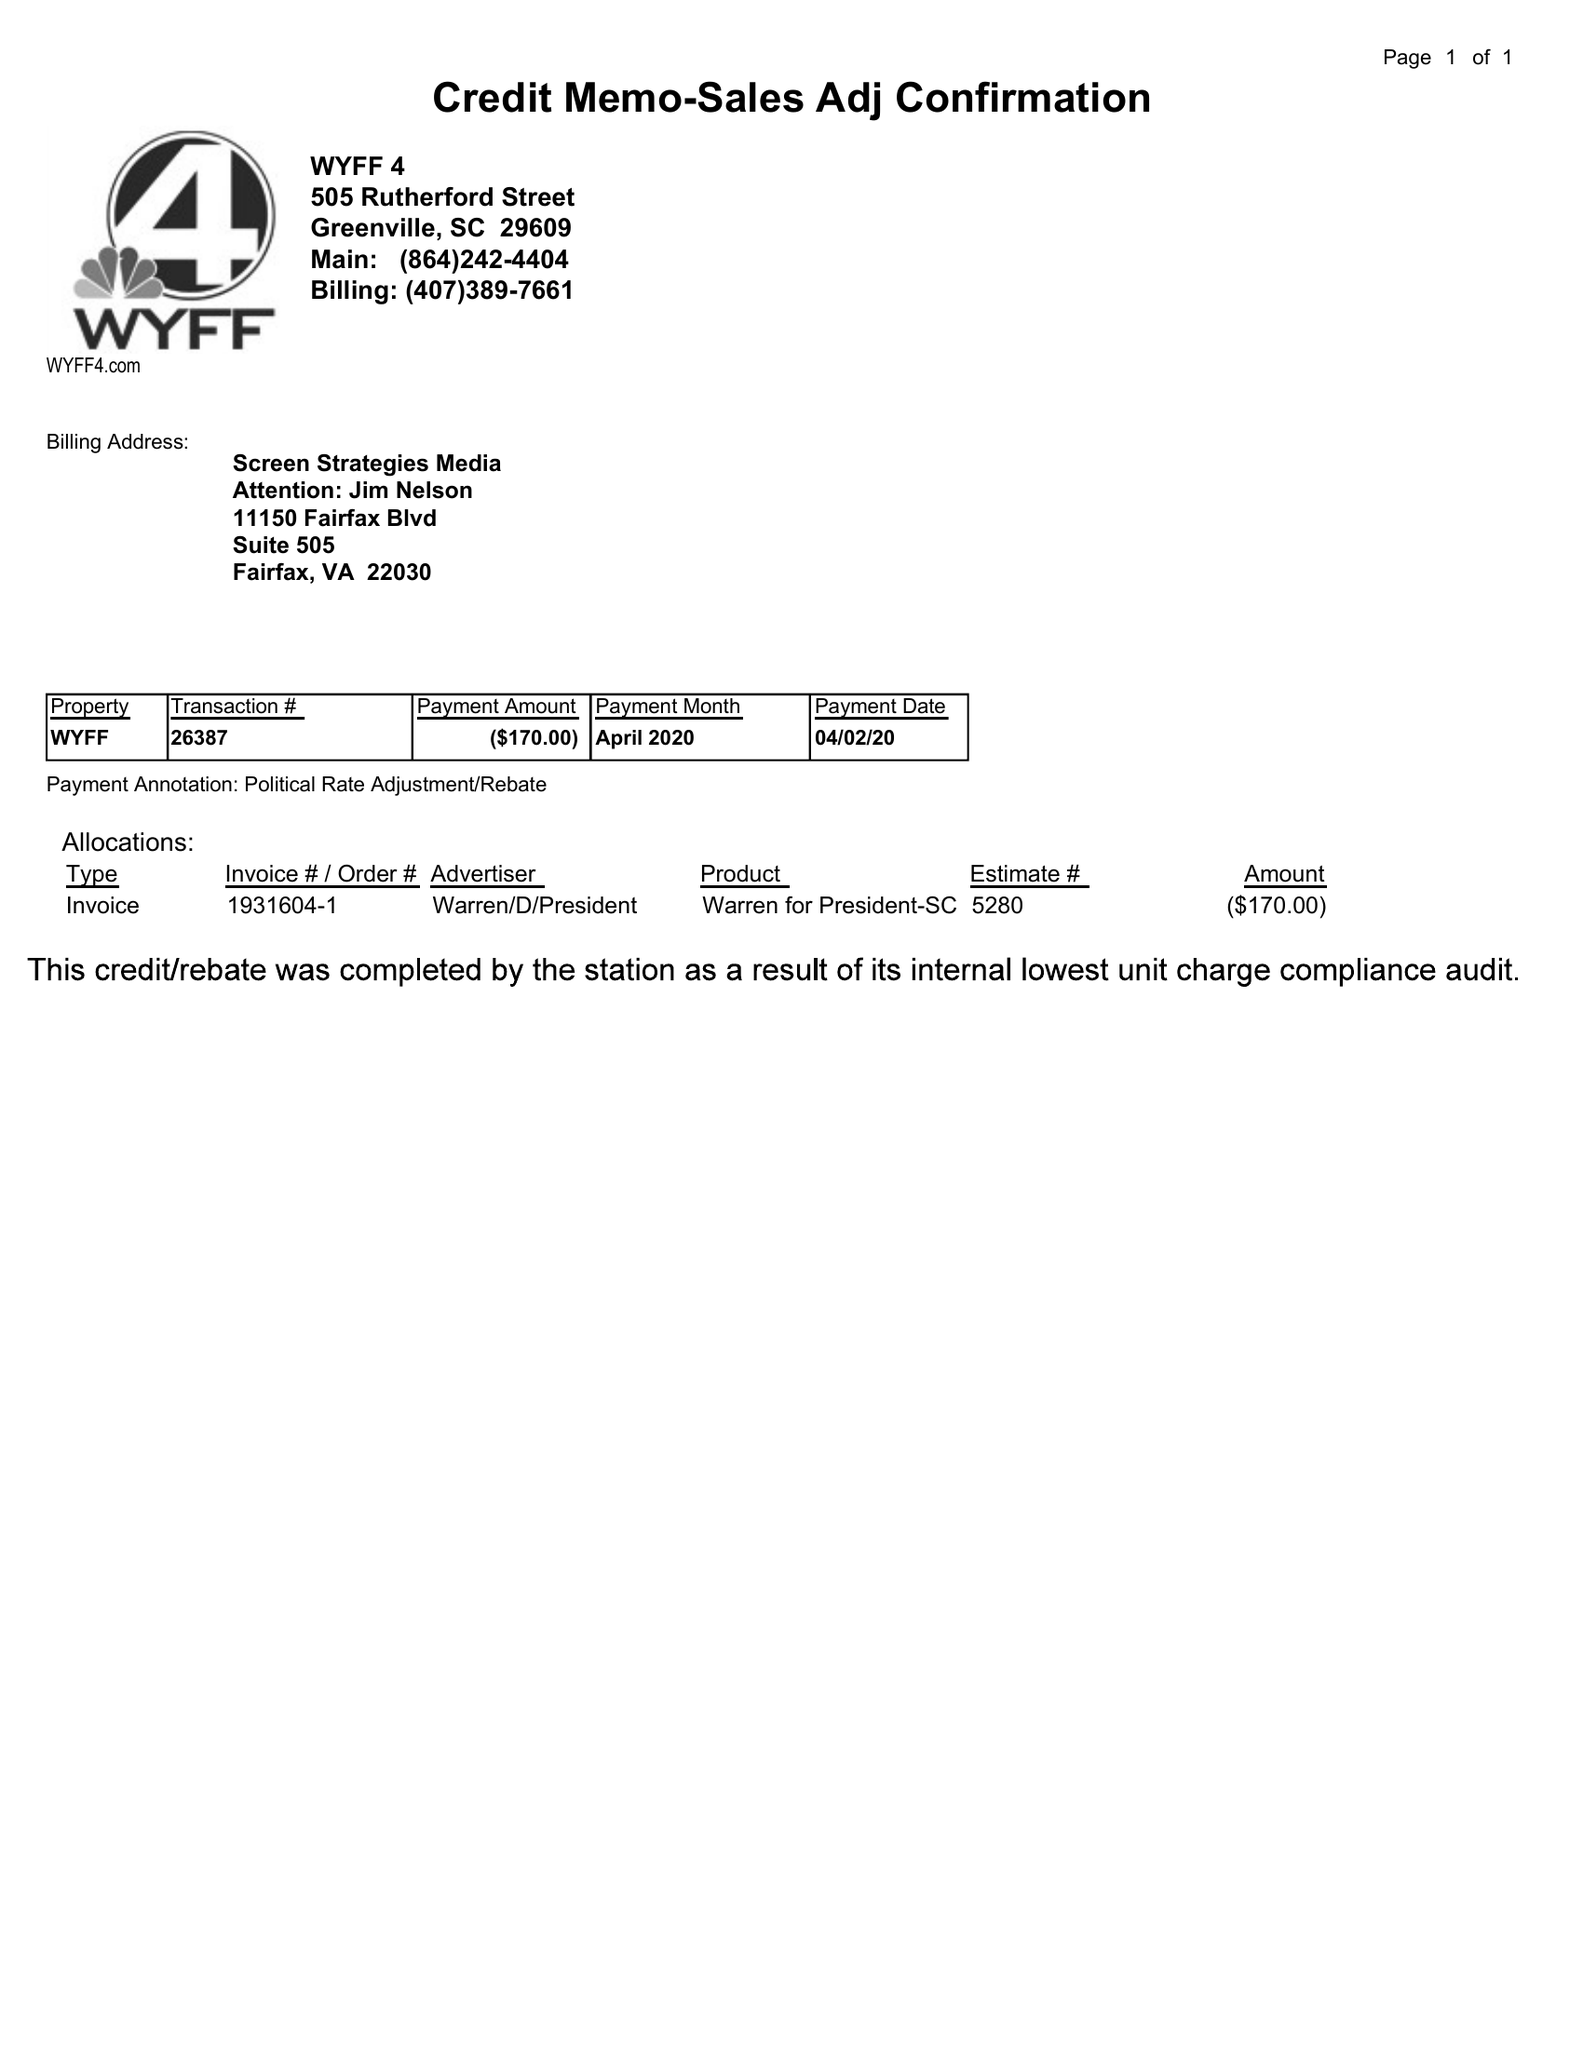What is the value for the gross_amount?
Answer the question using a single word or phrase. -170.00 